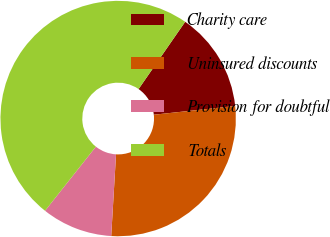Convert chart to OTSL. <chart><loc_0><loc_0><loc_500><loc_500><pie_chart><fcel>Charity care<fcel>Uninsured discounts<fcel>Provision for doubtful<fcel>Totals<nl><fcel>13.66%<fcel>27.64%<fcel>9.73%<fcel>48.97%<nl></chart> 